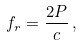<formula> <loc_0><loc_0><loc_500><loc_500>f _ { r } = \frac { 2 P } { c } \, ,</formula> 